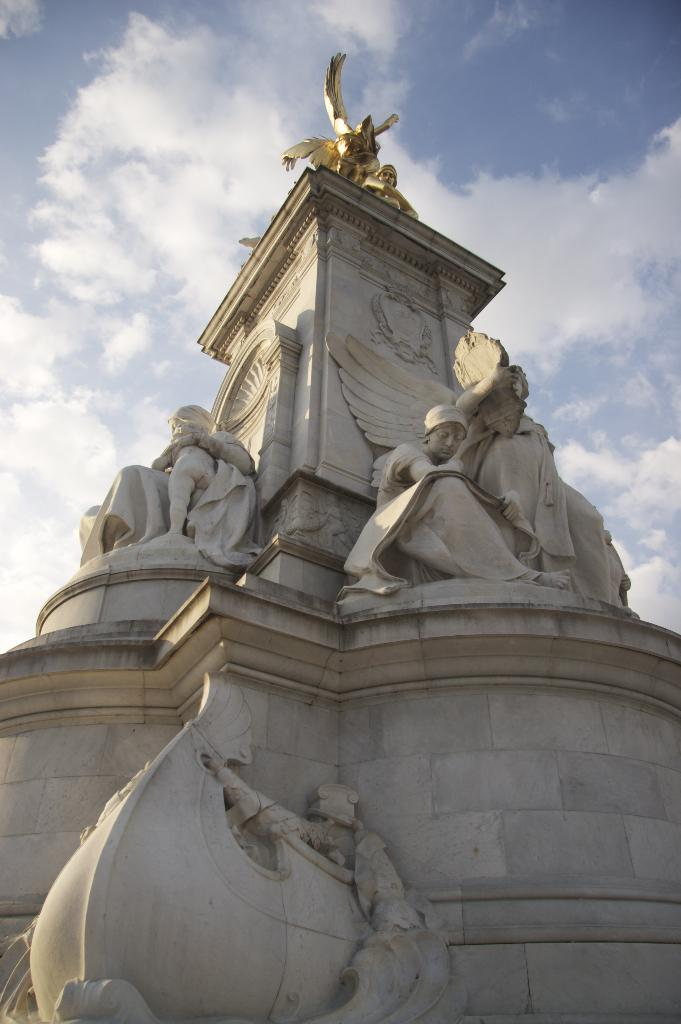What type of objects can be seen in the image? There are statues in the image. What is the background of the image? There is a wall in the image, and the sky is visible in the background. What can be seen in the sky? Clouds are present in the sky. What type of soup is being served in the image? There is no soup present in the image; it features statues, a wall, and the sky with clouds. 